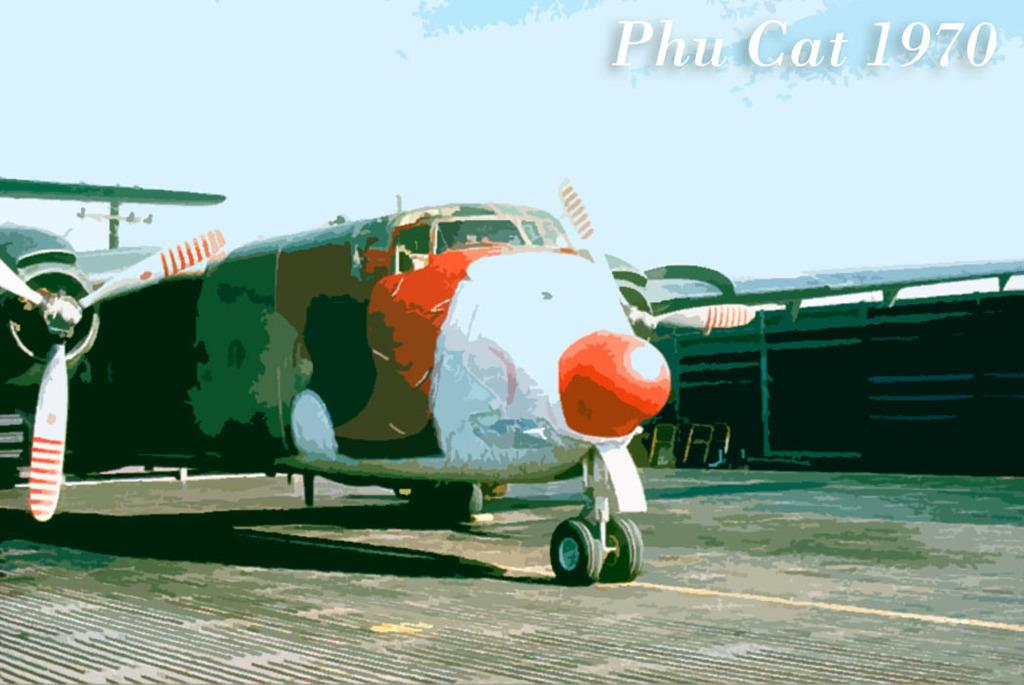What is depicted in the painting in the image? There is a painting of an aircraft in the image. What can be seen beside the aircraft in the image? There is a wooden fence beside the aircraft in the image. Is there any text visible in the image? Yes, there is some text visible at the top of the image. How many eggs are being used to paint the aircraft in the image? There is no indication in the image that eggs are being used to paint the aircraft; it is a painting, not an actual aircraft being painted. 